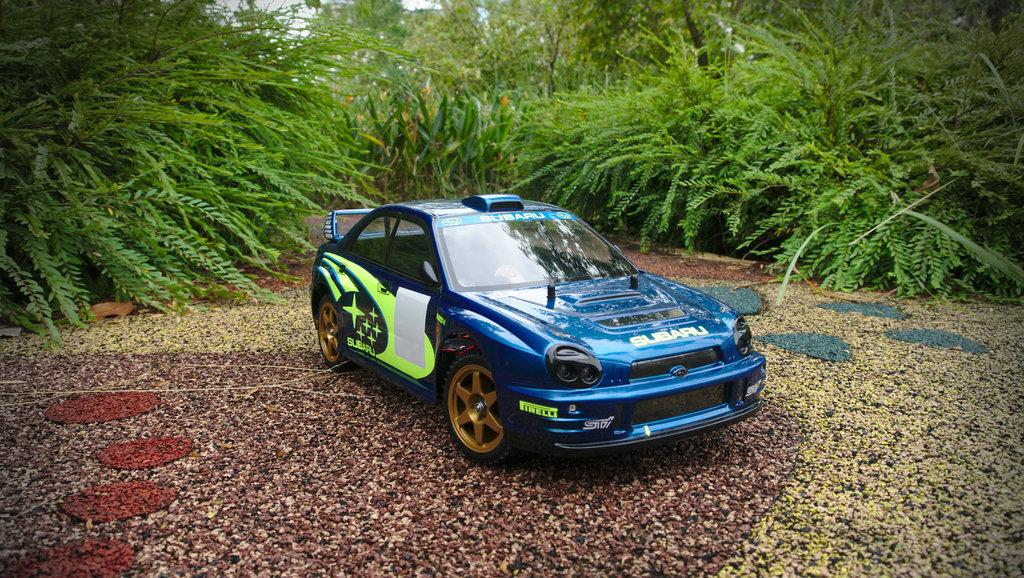What is the main subject of the image? There is a car in the image. Can you describe the color of the car? The car is blue. What can be seen in the background of the image? There are green trees in the background of the image. What type of book is the car offering to the trees in the image? There is no book or offer present in the image; it features a blue car with green trees in the background. 